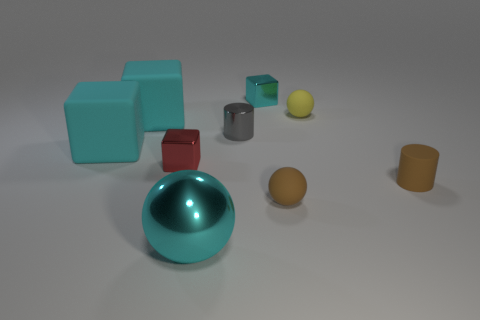Subtract all tiny red blocks. How many blocks are left? 3 Subtract all red cubes. How many cubes are left? 3 Subtract 3 cubes. How many cubes are left? 1 Subtract all cylinders. How many objects are left? 7 Subtract all green cylinders. Subtract all red spheres. How many cylinders are left? 2 Subtract all gray blocks. How many cyan cylinders are left? 0 Subtract all cyan rubber objects. Subtract all small gray metallic cylinders. How many objects are left? 6 Add 6 red blocks. How many red blocks are left? 7 Add 2 tiny brown rubber spheres. How many tiny brown rubber spheres exist? 3 Add 1 big purple cylinders. How many objects exist? 10 